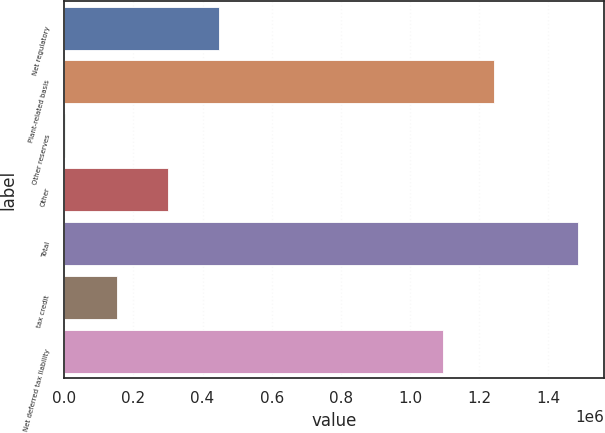Convert chart to OTSL. <chart><loc_0><loc_0><loc_500><loc_500><bar_chart><fcel>Net regulatory<fcel>Plant-related basis<fcel>Other reserves<fcel>Other<fcel>Total<fcel>tax credit<fcel>Net deferred tax liability<nl><fcel>447756<fcel>1.24267e+06<fcel>2686<fcel>299399<fcel>1.48625e+06<fcel>151043<fcel>1.09432e+06<nl></chart> 